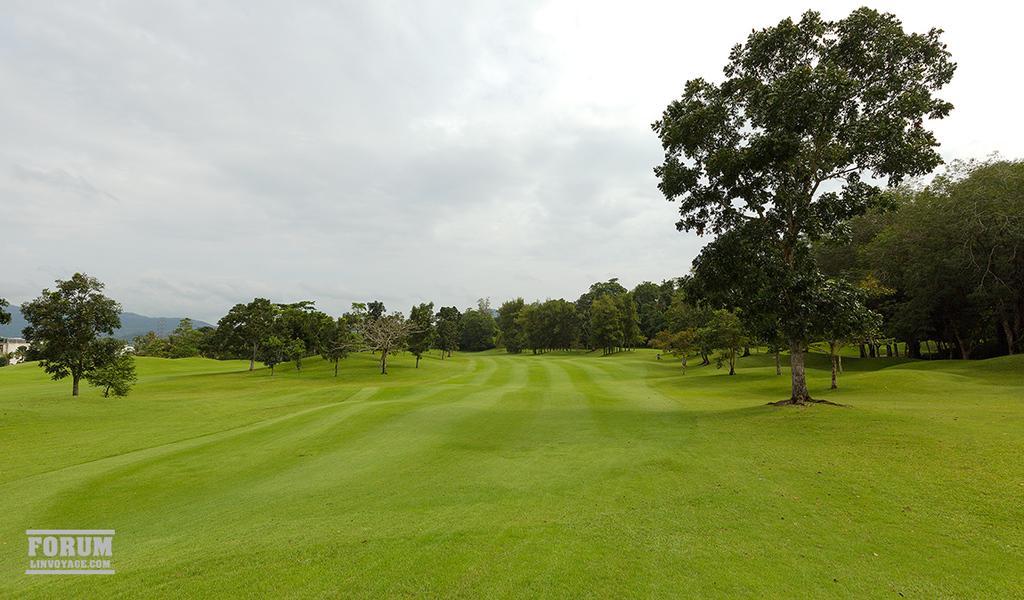Can you describe this image briefly? In this image there is the sky towards the top of the image, there are mountains towards the left of the image, there are trees, there is grass, there is text towards the bottom of the image. 